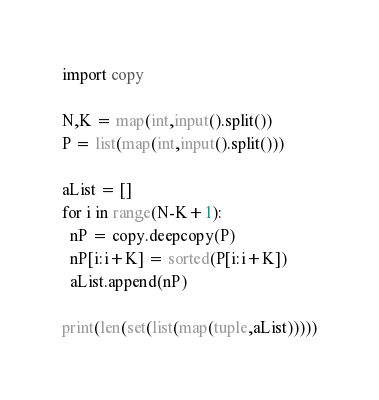<code> <loc_0><loc_0><loc_500><loc_500><_Python_>import copy

N,K = map(int,input().split())
P = list(map(int,input().split()))

aList = []
for i in range(N-K+1):
  nP = copy.deepcopy(P)
  nP[i:i+K] = sorted(P[i:i+K])
  aList.append(nP)

print(len(set(list(map(tuple,aList)))))</code> 